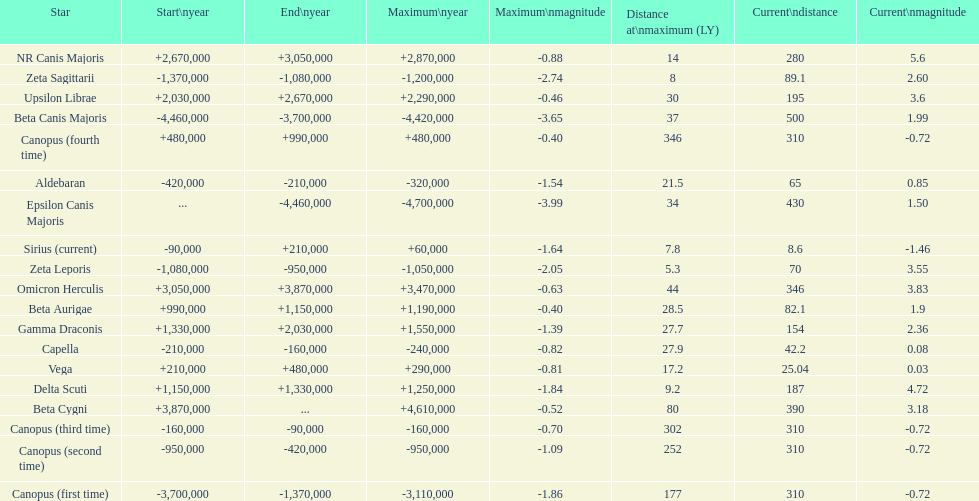How many stars have a magnitude greater than zero? 14. Parse the full table. {'header': ['Star', 'Start\\nyear', 'End\\nyear', 'Maximum\\nyear', 'Maximum\\nmagnitude', 'Distance at\\nmaximum (LY)', 'Current\\ndistance', 'Current\\nmagnitude'], 'rows': [['NR Canis Majoris', '+2,670,000', '+3,050,000', '+2,870,000', '-0.88', '14', '280', '5.6'], ['Zeta Sagittarii', '-1,370,000', '-1,080,000', '-1,200,000', '-2.74', '8', '89.1', '2.60'], ['Upsilon Librae', '+2,030,000', '+2,670,000', '+2,290,000', '-0.46', '30', '195', '3.6'], ['Beta Canis Majoris', '-4,460,000', '-3,700,000', '-4,420,000', '-3.65', '37', '500', '1.99'], ['Canopus (fourth time)', '+480,000', '+990,000', '+480,000', '-0.40', '346', '310', '-0.72'], ['Aldebaran', '-420,000', '-210,000', '-320,000', '-1.54', '21.5', '65', '0.85'], ['Epsilon Canis Majoris', '...', '-4,460,000', '-4,700,000', '-3.99', '34', '430', '1.50'], ['Sirius (current)', '-90,000', '+210,000', '+60,000', '-1.64', '7.8', '8.6', '-1.46'], ['Zeta Leporis', '-1,080,000', '-950,000', '-1,050,000', '-2.05', '5.3', '70', '3.55'], ['Omicron Herculis', '+3,050,000', '+3,870,000', '+3,470,000', '-0.63', '44', '346', '3.83'], ['Beta Aurigae', '+990,000', '+1,150,000', '+1,190,000', '-0.40', '28.5', '82.1', '1.9'], ['Gamma Draconis', '+1,330,000', '+2,030,000', '+1,550,000', '-1.39', '27.7', '154', '2.36'], ['Capella', '-210,000', '-160,000', '-240,000', '-0.82', '27.9', '42.2', '0.08'], ['Vega', '+210,000', '+480,000', '+290,000', '-0.81', '17.2', '25.04', '0.03'], ['Delta Scuti', '+1,150,000', '+1,330,000', '+1,250,000', '-1.84', '9.2', '187', '4.72'], ['Beta Cygni', '+3,870,000', '...', '+4,610,000', '-0.52', '80', '390', '3.18'], ['Canopus (third time)', '-160,000', '-90,000', '-160,000', '-0.70', '302', '310', '-0.72'], ['Canopus (second time)', '-950,000', '-420,000', '-950,000', '-1.09', '252', '310', '-0.72'], ['Canopus (first time)', '-3,700,000', '-1,370,000', '-3,110,000', '-1.86', '177', '310', '-0.72']]} 